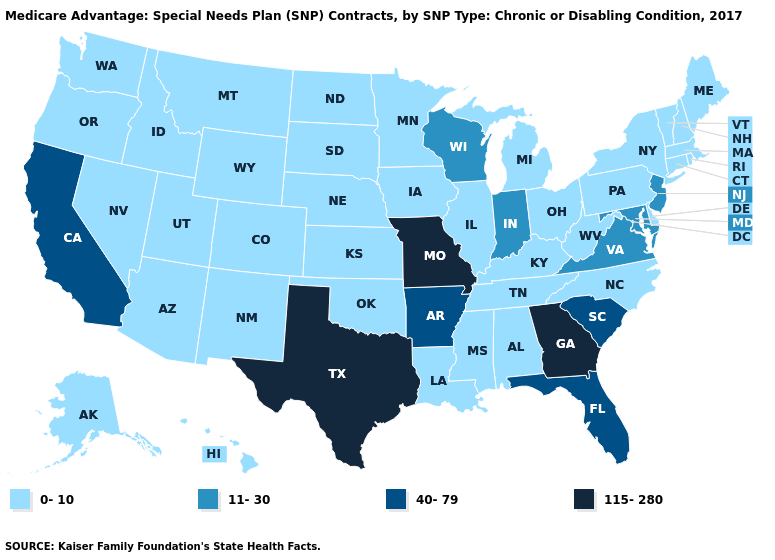What is the value of North Dakota?
Short answer required. 0-10. Is the legend a continuous bar?
Concise answer only. No. What is the lowest value in states that border South Dakota?
Give a very brief answer. 0-10. What is the value of Arkansas?
Give a very brief answer. 40-79. Name the states that have a value in the range 115-280?
Concise answer only. Georgia, Missouri, Texas. Does Florida have the highest value in the South?
Give a very brief answer. No. Name the states that have a value in the range 40-79?
Quick response, please. Arkansas, California, Florida, South Carolina. Name the states that have a value in the range 0-10?
Short answer required. Alaska, Alabama, Arizona, Colorado, Connecticut, Delaware, Hawaii, Iowa, Idaho, Illinois, Kansas, Kentucky, Louisiana, Massachusetts, Maine, Michigan, Minnesota, Mississippi, Montana, North Carolina, North Dakota, Nebraska, New Hampshire, New Mexico, Nevada, New York, Ohio, Oklahoma, Oregon, Pennsylvania, Rhode Island, South Dakota, Tennessee, Utah, Vermont, Washington, West Virginia, Wyoming. What is the lowest value in the USA?
Short answer required. 0-10. Among the states that border Idaho , which have the highest value?
Give a very brief answer. Montana, Nevada, Oregon, Utah, Washington, Wyoming. Does Virginia have a higher value than California?
Short answer required. No. What is the lowest value in states that border Michigan?
Short answer required. 0-10. Does Alaska have a lower value than New York?
Give a very brief answer. No. Name the states that have a value in the range 115-280?
Keep it brief. Georgia, Missouri, Texas. 